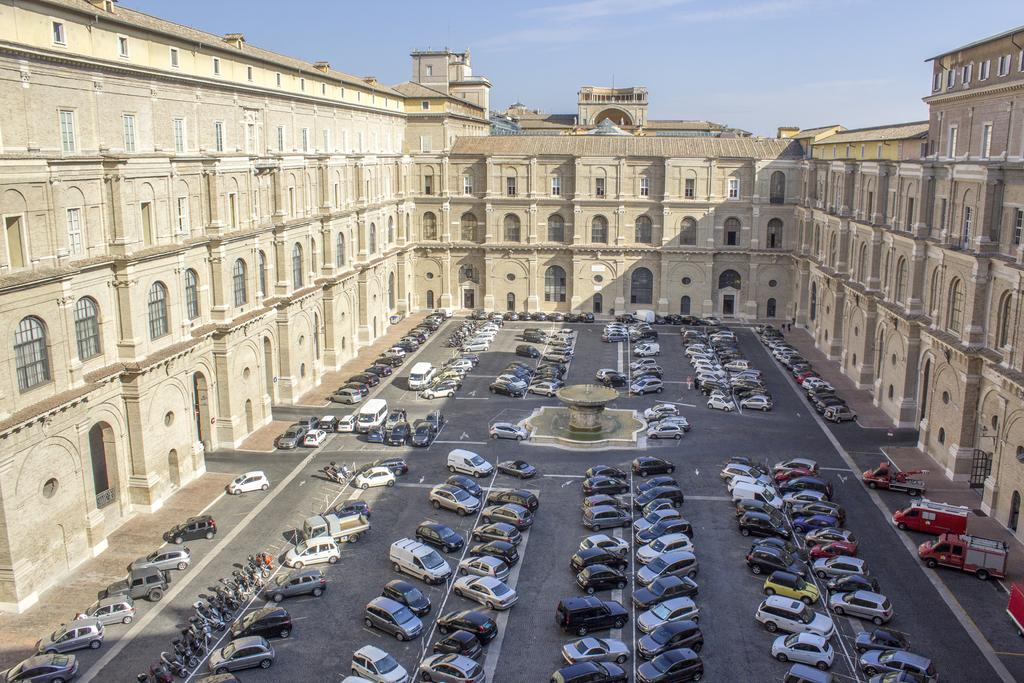What types of objects are present in the image? There are vehicles, a fountain, and a building in the image. What can be seen in the background of the image? The sky is visible at the top of the image. Can you describe the fountain in the image? The fountain is a device that provides assistance or support, but there is no such device mentioned in the image. The image contains a fountain, which is a structure that sprays water for decorative or functional purposes. What type of meal is being served in the image? There is no meal present in the image; it features vehicles, a fountain, and a building. What degree of difficulty is required to inflate the balloon in the image? There is no balloon present in the image, so it is not possible to determine the degree of difficulty required to inflate it. 